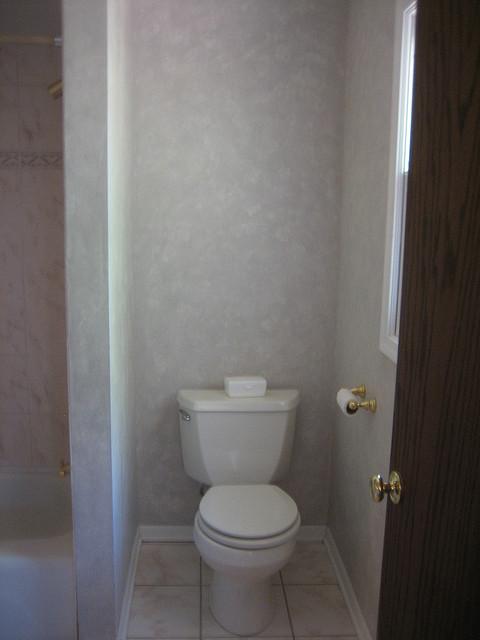Does this bathroom need to be renovated?
Concise answer only. No. Is there any toilet paper?
Give a very brief answer. Yes. Where is the brush to clean the toilet?
Answer briefly. In closet. Is this a clean bathroom?
Keep it brief. Yes. What color is the door handle?
Write a very short answer. Gold. Is the bathroom dirty or clean?
Give a very brief answer. Clean. Is there a trash can?
Answer briefly. No. Is there toilet paper in this bathroom?
Keep it brief. Yes. 